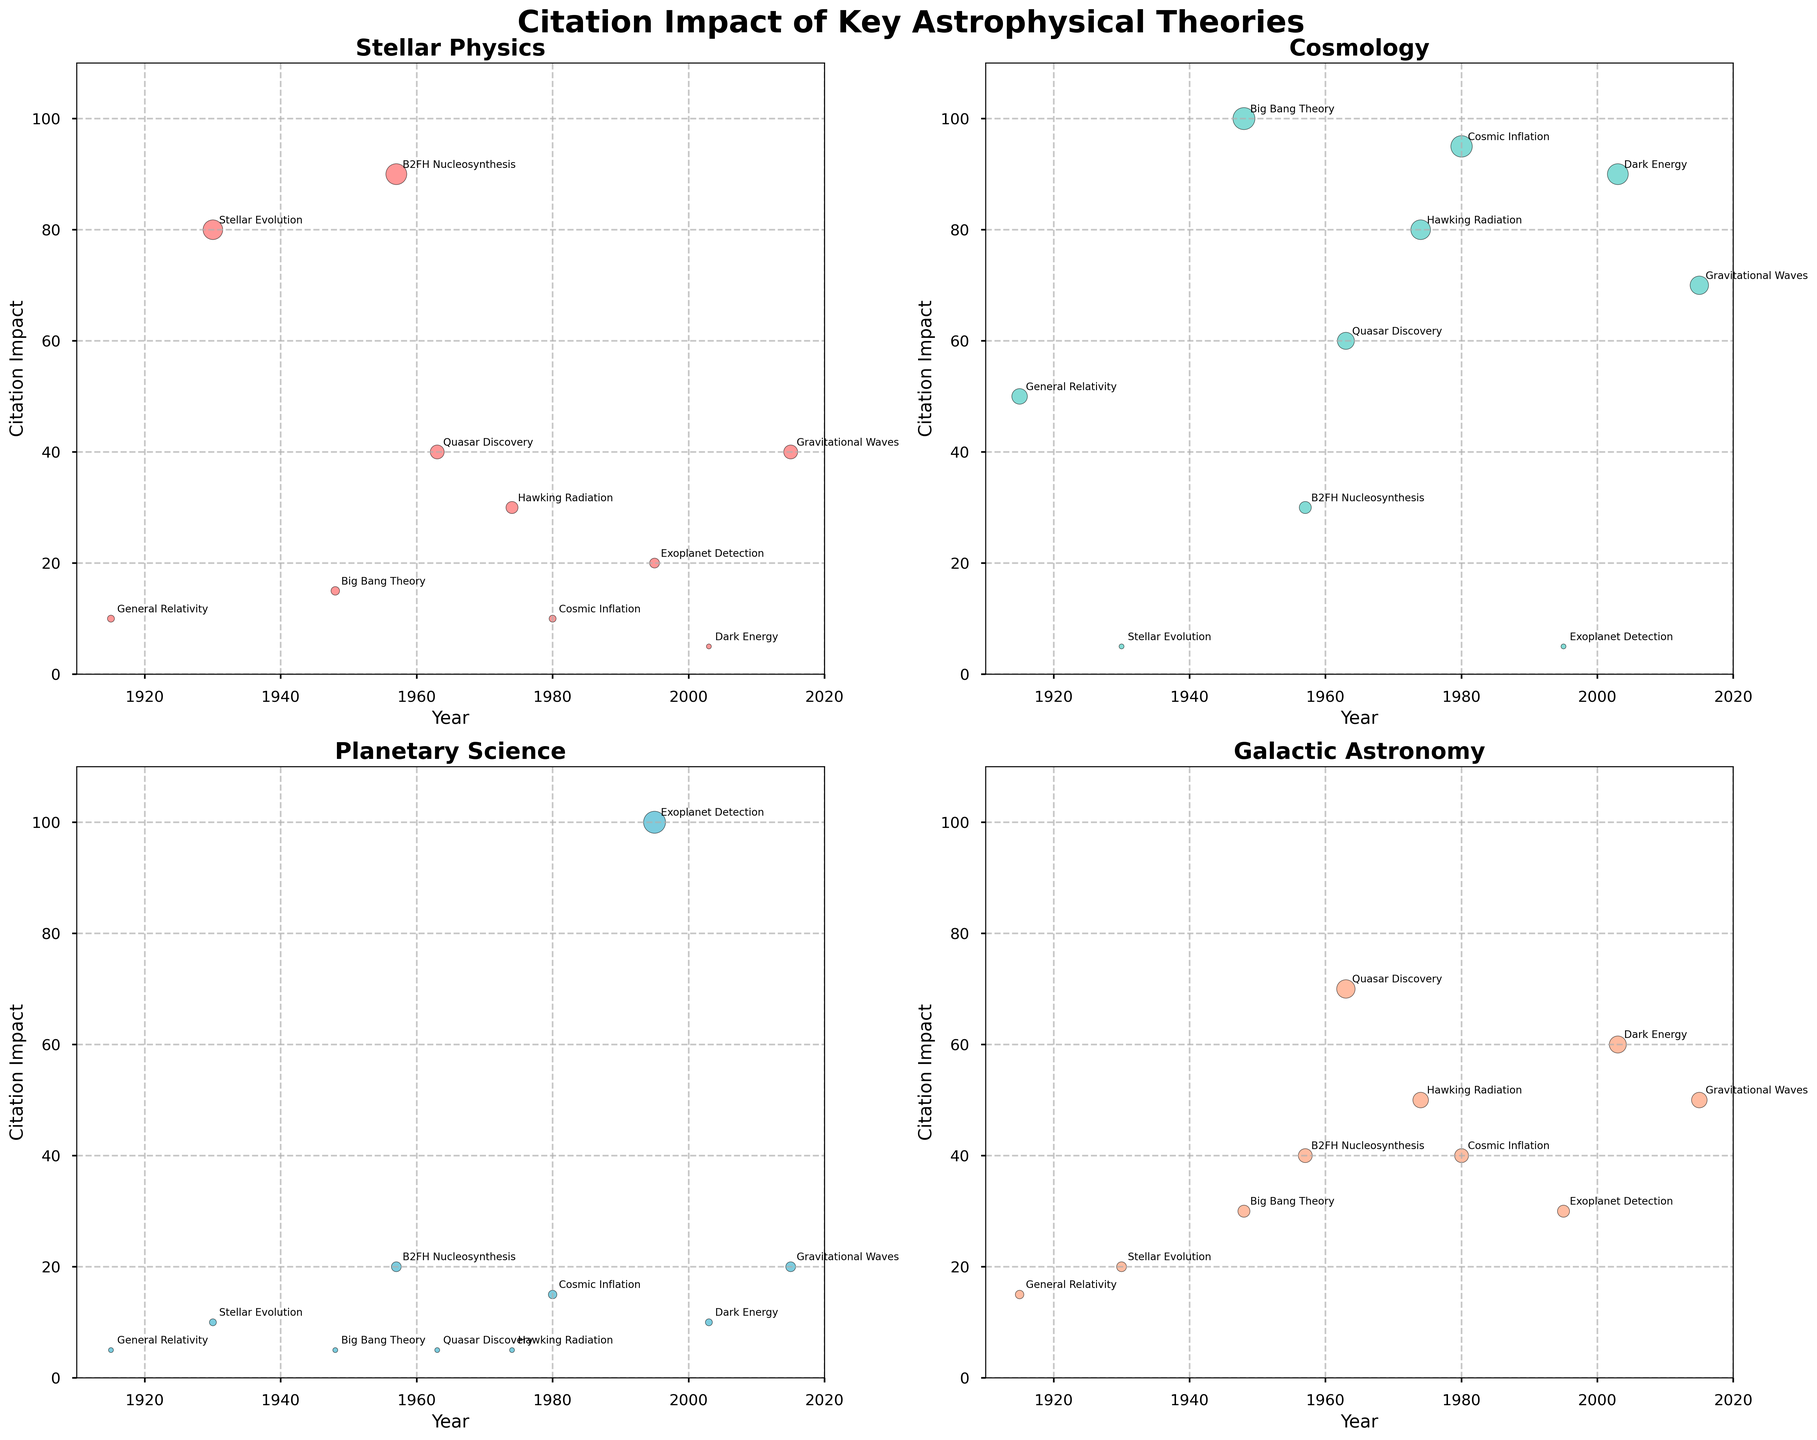Which theory has the highest citation impact in Stellar Physics? To find the highest citation impact in Stellar Physics, look at the scatter plot for Stellar Physics and identify the data point with the highest value on the y-axis. The theory with the highest value is Stellar Evolution.
Answer: Stellar Evolution How many theories have a citation impact greater than 50 in Cosmology? To determine this, we examine the scatter plot for Cosmology and count the number of data points above the y-axis value 50. These are General Relativity, Big Bang Theory, Hawking Radiation, Cosmic Inflation, and Dark Energy. There are 5 theories.
Answer: 5 Which theory has the lowest citation impact in Planetary Science? Look at the scatter plot for Planetary Science and find the data point with the lowest value on the y-axis. Both General Relativity, Big Bang Theory, Quasar Discovery, and Hawking Radiation have the lowest values of 5.
Answer: General Relativity, Big Bang Theory, Quasar Discovery, Hawking Radiation In which discipline does the theory of Cosmic Inflation have the highest citation impact? Check the scatter plot points for Cosmic Inflation across all four disciplines. Identify the highest citation impact among these. Cosmic Inflation has the highest citation impact in Cosmology.
Answer: Cosmology Compare the citation impact of Gravitational Waves in Stellar Physics and Galactic Astronomy. Which is higher? Observe the values for Gravitational Waves in both scatter plots for Stellar Physics and Galactic Astronomy. The citation impacts are 40 for Stellar Physics and 50 for Galactic Astronomy. Galactic Astronomy is higher.
Answer: Galactic Astronomy What is the total citation impact of Quasar Discovery across all disciplines? Sum the citation impacts of Quasar Discovery in each discipline: Stellar Physics (40), Cosmology (60), Planetary Science (5), and Galactic Astronomy (70). The total is 40 + 60 + 5 + 70 = 175.
Answer: 175 Which theory had a significant impact on both Cosmology and Galactic Astronomy in the 40s timeframe? Look at the scatter plot and locate the theories with high citation impact near the 40s period. The Big Bang Theory (1948) had significant impacts in both Cosmology (100) and Galactic Astronomy (30).
Answer: Big Bang Theory How does the citation impact of Exoplanet Detection in Planetary Science compare to its impact in Stellar Physics? Compare the values for Exoplanet Detection in the scatter plots for Planetary Science and Stellar Physics. Exoplanet Detection has a citation impact of 100 in Planetary Science and 20 in Stellar Physics. The impact in Planetary Science is higher.
Answer: Planetary Science has a higher citation impact What is the average citation impact of all theories in Galactic Astronomy? Sum the citation impacts of all theories in the Galactic Astronomy scatter plot and divide by the total number of theories. The sums are: 15 + 20 + 30 + 40 + 70 + 50 + 40 + 30 + 60 + 50 = 405. There are 10 theories, so the average is 405 / 10 = 40.5.
Answer: 40.5 